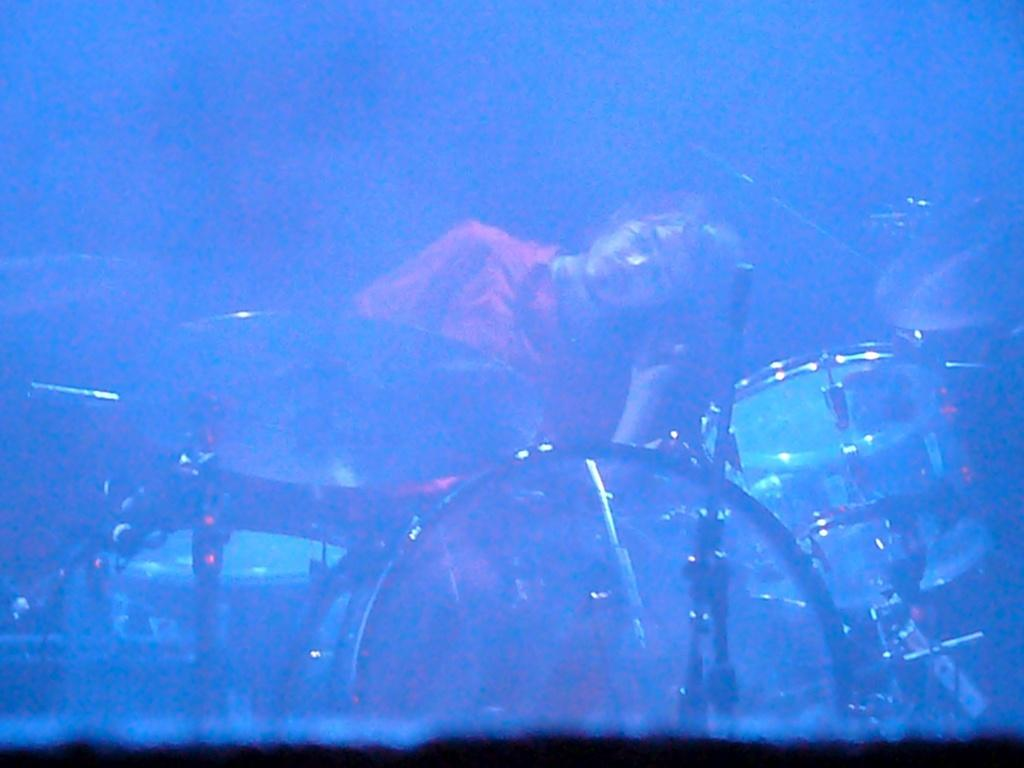Who is the main subject in the image? There is a man in the image. What is the man doing in the image? The man is in front of drums. What type of cough medicine is the man holding in the image? There is no cough medicine present in the image; the man is in front of drums. How many cattle can be seen in the image? There are no cattle present in the image; the main subject is a man in front of drums. 